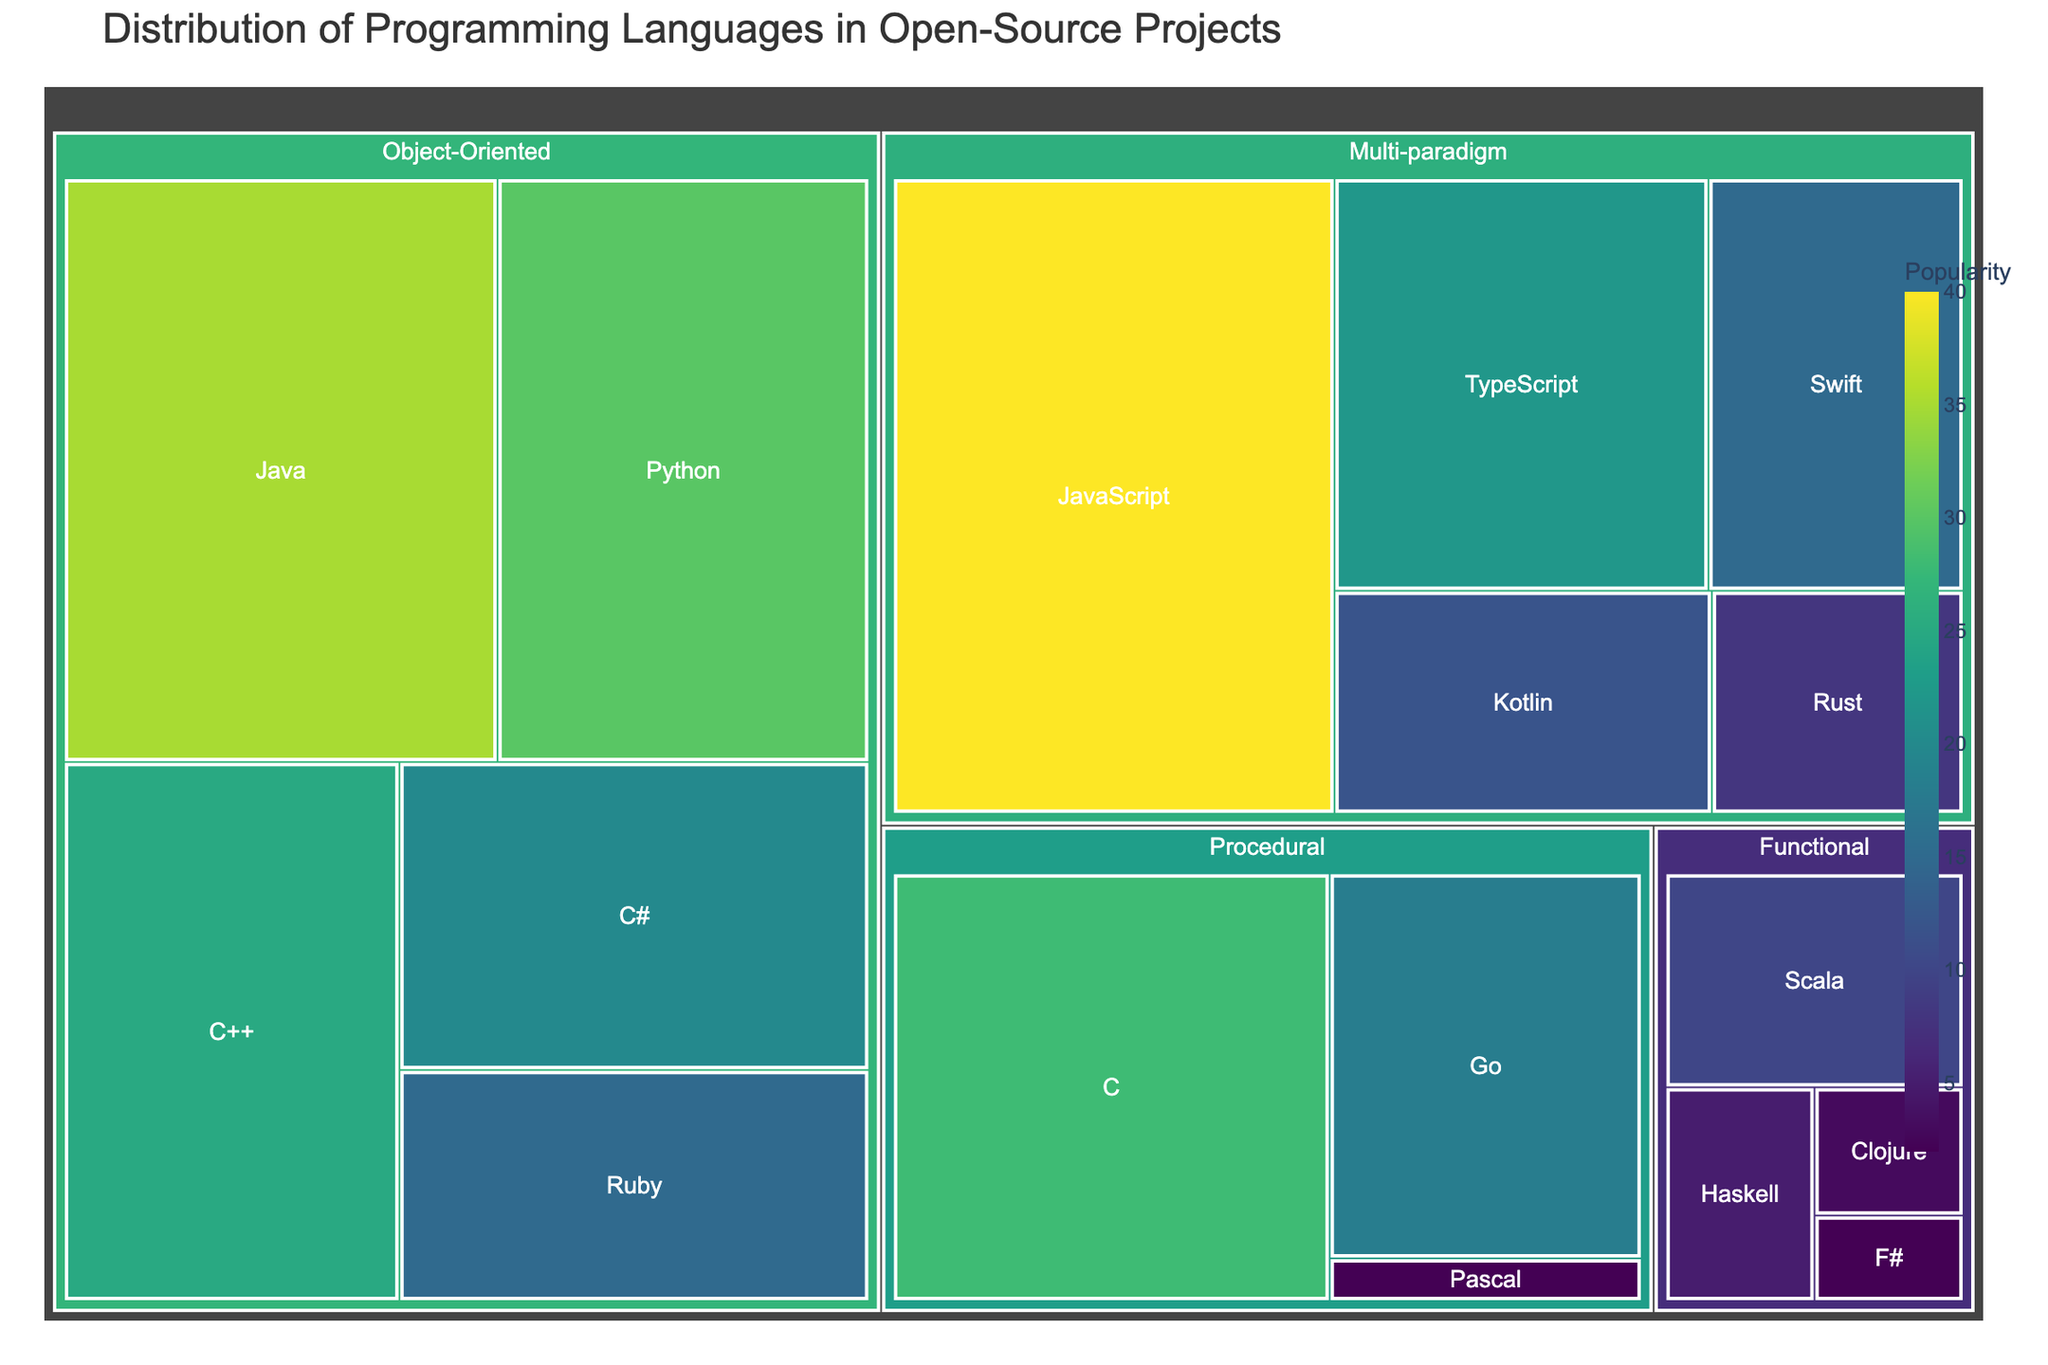What is the title of the treemap? The title of the treemap is found at the top and it usually describes the main subject of the visual representation
Answer: Distribution of Programming Languages in Open-Source Projects Which programming language has the highest popularity? Look for the programming language with the largest area in the treemap, indicating the highest popularity value
Answer: JavaScript Under the Object-Oriented paradigm, which language has the lowest popularity? Navigate to the Object-Oriented section and identify which language has the smallest area
Answer: Ruby How many paradigms are represented in the treemap? Count the number of distinct sections along the first level of the hierarchy which represents different paradigms
Answer: Four What is the combined popularity of all functional programming languages? Add the individual popularity values for Haskell, Scala, Clojure, and F#
Answer: 20 Which programming language is more popular: Python or C++? Compare the sizes of the areas corresponding to Python and C++ within the Object-Oriented paradigm
Answer: Python What percentage of the total popularity is attributed to Multi-paradigm languages? Sum the popularity values of JavaScript, TypeScript, Kotlin, Swift, and Rust, then divide by the total popularity value of all languages and multiply by 100
Answer: 33% Is Go more popular than C#? Compare the respective areas corresponding to Go and C#
Answer: No What is the least popular language in the entire treemap? Identify the language with the smallest area on the treemap which indicates the lowest popularity value
Answer: F# Compare the combined popularity of Procedural languages to Object-Oriented languages. Which group is more popular? Sum the popularity values for Procedural languages: C, Go, Pascal and for Object-Oriented languages: Java, C++, Python, C#, Ruby and compare the two sums
Answer: Object-Oriented (125 vs. 48) 